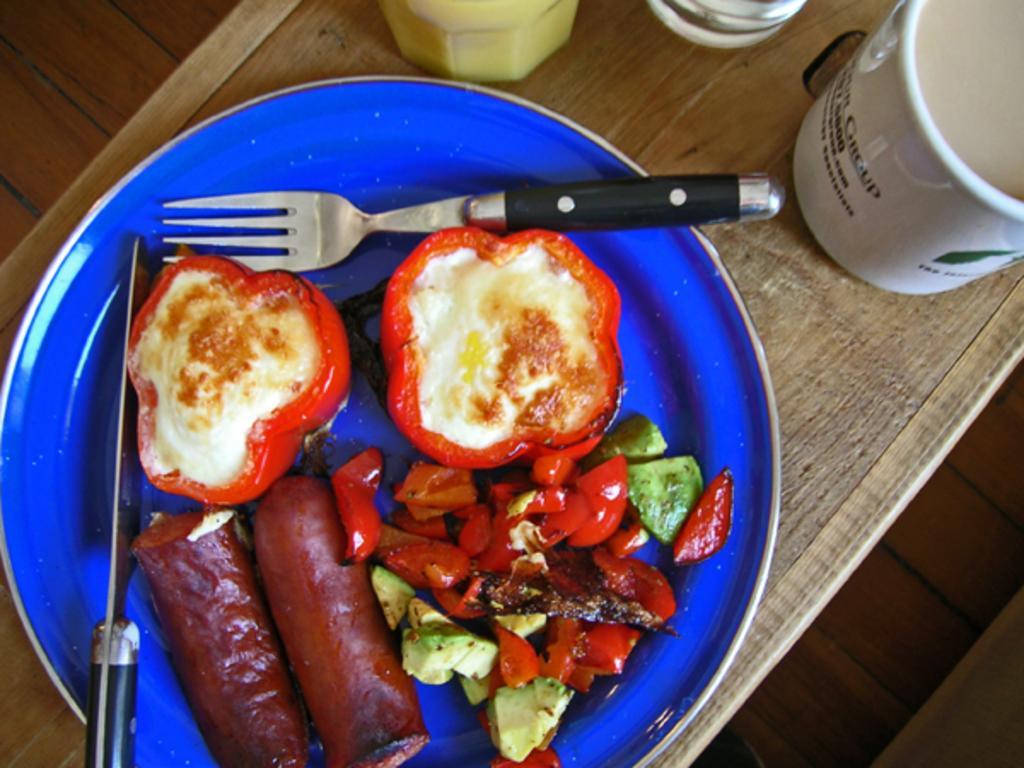How would you summarize this image in a sentence or two? In this image there is a plate, cup and few objects are on the table. On the plate there is some food, knife and a fork. 